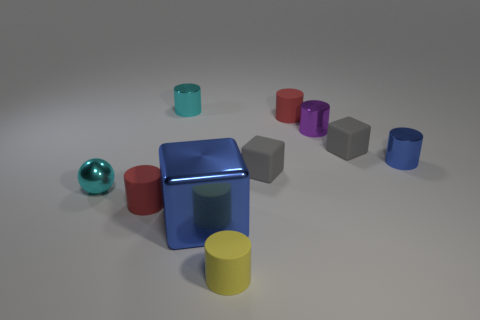Subtract all small blocks. How many blocks are left? 1 Subtract all purple cylinders. How many cylinders are left? 5 Subtract all cubes. How many objects are left? 7 Subtract all brown balls. How many cyan cylinders are left? 1 Subtract 1 yellow cylinders. How many objects are left? 9 Subtract 4 cylinders. How many cylinders are left? 2 Subtract all yellow cubes. Subtract all brown cylinders. How many cubes are left? 3 Subtract all shiny cylinders. Subtract all cyan metal balls. How many objects are left? 6 Add 2 small matte objects. How many small matte objects are left? 7 Add 7 purple cubes. How many purple cubes exist? 7 